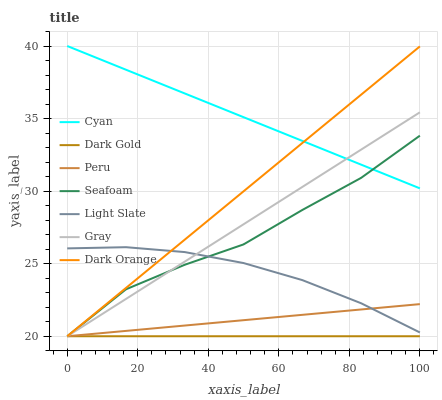Does Dark Gold have the minimum area under the curve?
Answer yes or no. Yes. Does Cyan have the maximum area under the curve?
Answer yes or no. Yes. Does Light Slate have the minimum area under the curve?
Answer yes or no. No. Does Light Slate have the maximum area under the curve?
Answer yes or no. No. Is Dark Gold the smoothest?
Answer yes or no. Yes. Is Seafoam the roughest?
Answer yes or no. Yes. Is Light Slate the smoothest?
Answer yes or no. No. Is Light Slate the roughest?
Answer yes or no. No. Does Gray have the lowest value?
Answer yes or no. Yes. Does Light Slate have the lowest value?
Answer yes or no. No. Does Cyan have the highest value?
Answer yes or no. Yes. Does Light Slate have the highest value?
Answer yes or no. No. Is Peru less than Cyan?
Answer yes or no. Yes. Is Cyan greater than Light Slate?
Answer yes or no. Yes. Does Seafoam intersect Gray?
Answer yes or no. Yes. Is Seafoam less than Gray?
Answer yes or no. No. Is Seafoam greater than Gray?
Answer yes or no. No. Does Peru intersect Cyan?
Answer yes or no. No. 